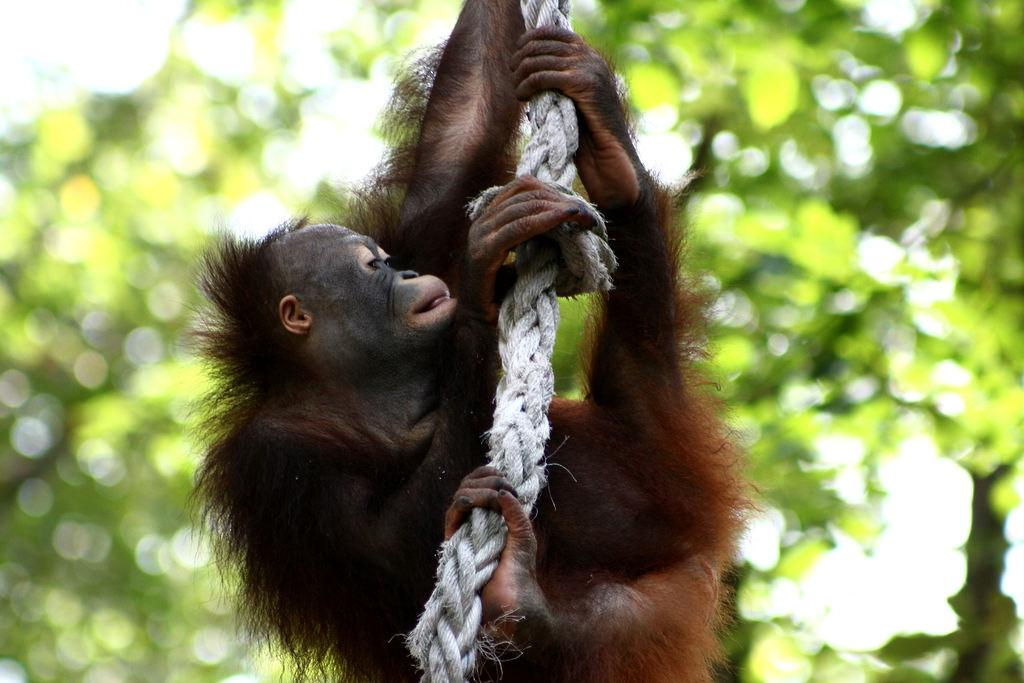What type of creature can be seen in the image? There is an animal in the image. What is the animal doing in the image? The animal is holding a rope. What can be seen in the distance in the image? There are trees visible in the background of the image. How would you describe the quality of the image? The image is blurry. How many eyes can be seen on the leaf in the image? There is no leaf present in the image, and therefore no eyes can be seen on it. 